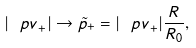<formula> <loc_0><loc_0><loc_500><loc_500>| { \ p v } _ { + } | \to \tilde { p } _ { + } = | { \ p v } _ { + } | \frac { R } { R _ { 0 } } ,</formula> 